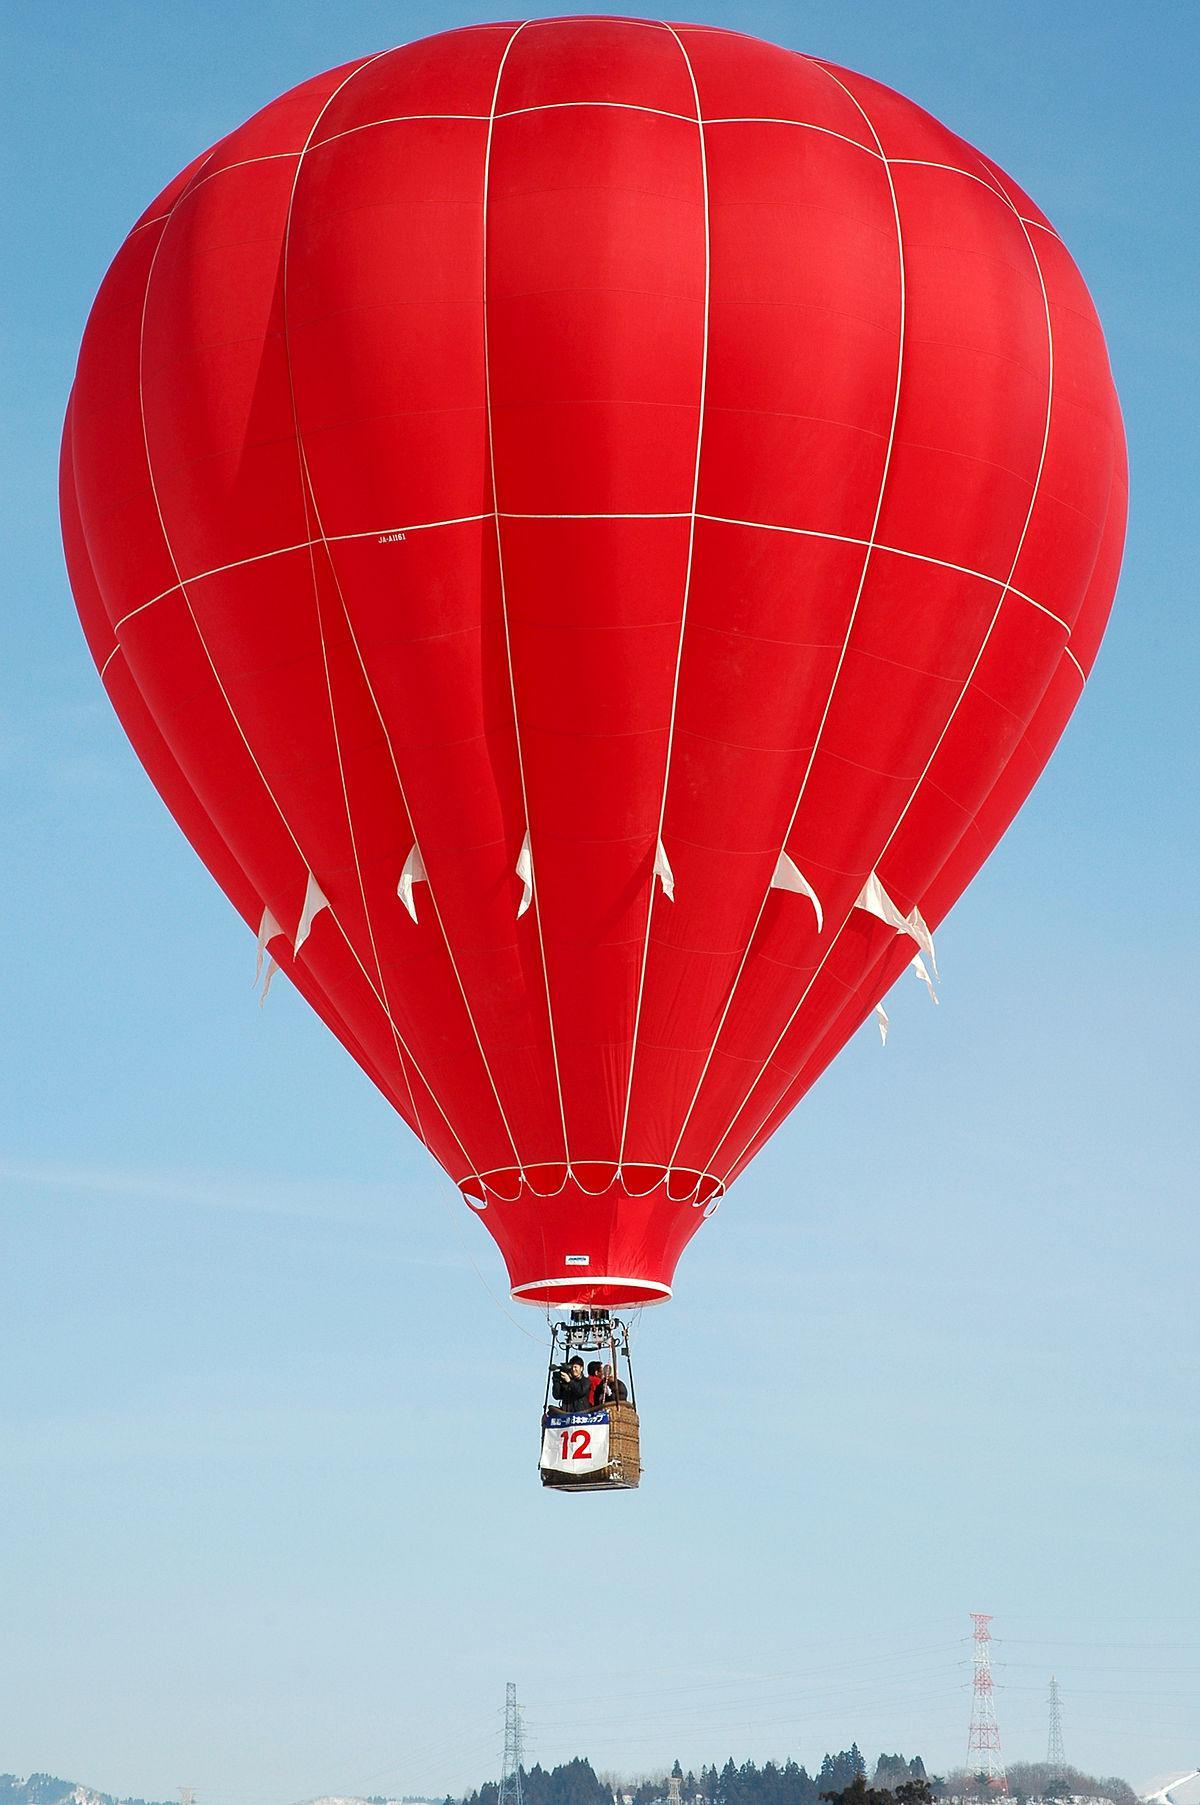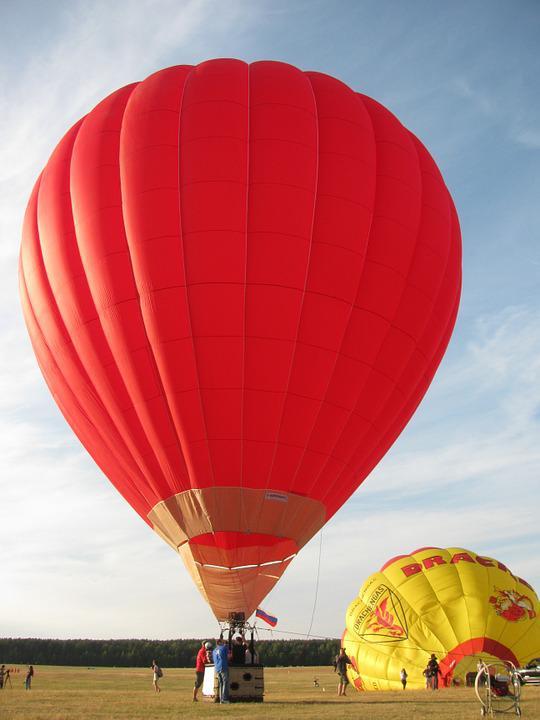The first image is the image on the left, the second image is the image on the right. Evaluate the accuracy of this statement regarding the images: "Two hot air balloons are predominantly red and have baskets for passengers.". Is it true? Answer yes or no. Yes. 